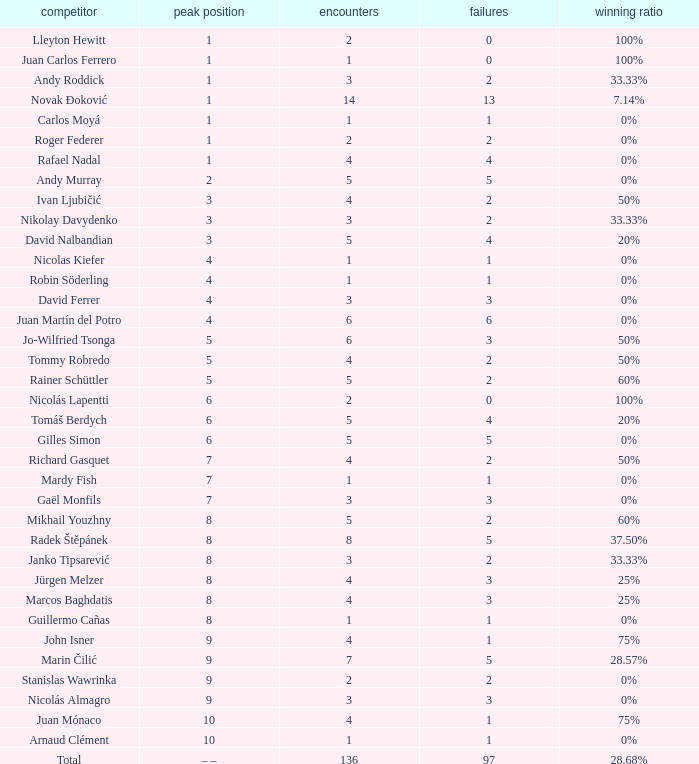What is the total number of Lost for the Highest Ranking of – –? 1.0. 